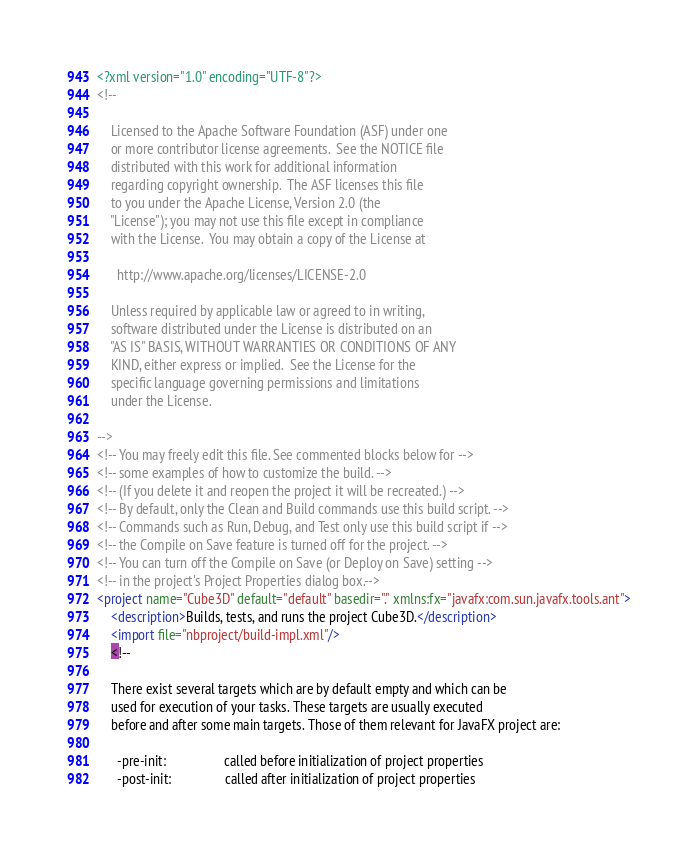Convert code to text. <code><loc_0><loc_0><loc_500><loc_500><_XML_><?xml version="1.0" encoding="UTF-8"?>
<!--

    Licensed to the Apache Software Foundation (ASF) under one
    or more contributor license agreements.  See the NOTICE file
    distributed with this work for additional information
    regarding copyright ownership.  The ASF licenses this file
    to you under the Apache License, Version 2.0 (the
    "License"); you may not use this file except in compliance
    with the License.  You may obtain a copy of the License at

      http://www.apache.org/licenses/LICENSE-2.0

    Unless required by applicable law or agreed to in writing,
    software distributed under the License is distributed on an
    "AS IS" BASIS, WITHOUT WARRANTIES OR CONDITIONS OF ANY
    KIND, either express or implied.  See the License for the
    specific language governing permissions and limitations
    under the License.

-->
<!-- You may freely edit this file. See commented blocks below for -->
<!-- some examples of how to customize the build. -->
<!-- (If you delete it and reopen the project it will be recreated.) -->
<!-- By default, only the Clean and Build commands use this build script. -->
<!-- Commands such as Run, Debug, and Test only use this build script if -->
<!-- the Compile on Save feature is turned off for the project. -->
<!-- You can turn off the Compile on Save (or Deploy on Save) setting -->
<!-- in the project's Project Properties dialog box.-->
<project name="Cube3D" default="default" basedir="." xmlns:fx="javafx:com.sun.javafx.tools.ant">
    <description>Builds, tests, and runs the project Cube3D.</description>
    <import file="nbproject/build-impl.xml"/>
    <!--

    There exist several targets which are by default empty and which can be
    used for execution of your tasks. These targets are usually executed
    before and after some main targets. Those of them relevant for JavaFX project are: 

      -pre-init:                 called before initialization of project properties
      -post-init:                called after initialization of project properties</code> 